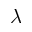Convert formula to latex. <formula><loc_0><loc_0><loc_500><loc_500>\lambda</formula> 